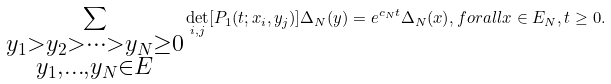<formula> <loc_0><loc_0><loc_500><loc_500>\sum _ { \substack { y _ { 1 } > y _ { 2 } > \dots > y _ { N } \geq 0 \\ y _ { 1 } , \dots , y _ { N } \in E } } { \det _ { i , j } [ P _ { 1 } ( t ; x _ { i } , y _ { j } ) ] \Delta _ { N } ( y ) } = e ^ { c _ { N } t } \Delta _ { N } ( x ) , f o r a l l x \in E _ { N } , t \geq 0 .</formula> 